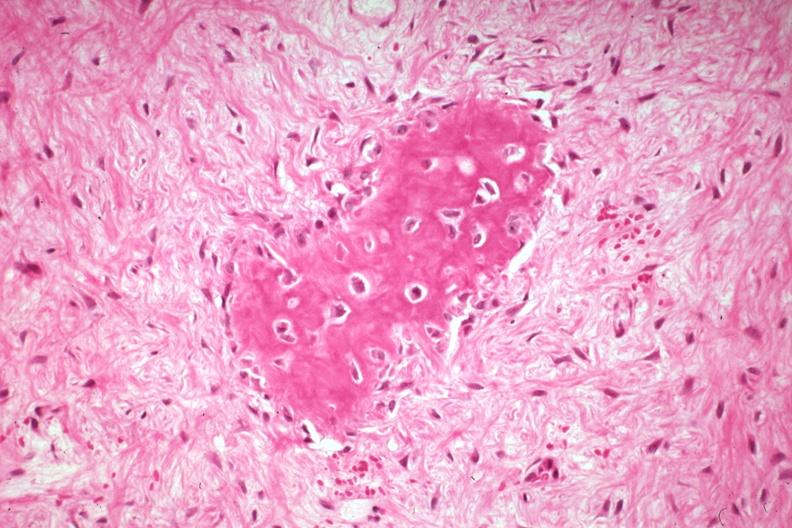what is present?
Answer the question using a single word or phrase. Joints 